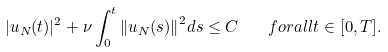Convert formula to latex. <formula><loc_0><loc_0><loc_500><loc_500>| u _ { N } ( t ) | ^ { 2 } + \nu \int _ { 0 } ^ { t } { \| u _ { N } ( s ) \| } ^ { 2 } d s \leq C \quad f o r a l l t \in [ 0 , T ] .</formula> 